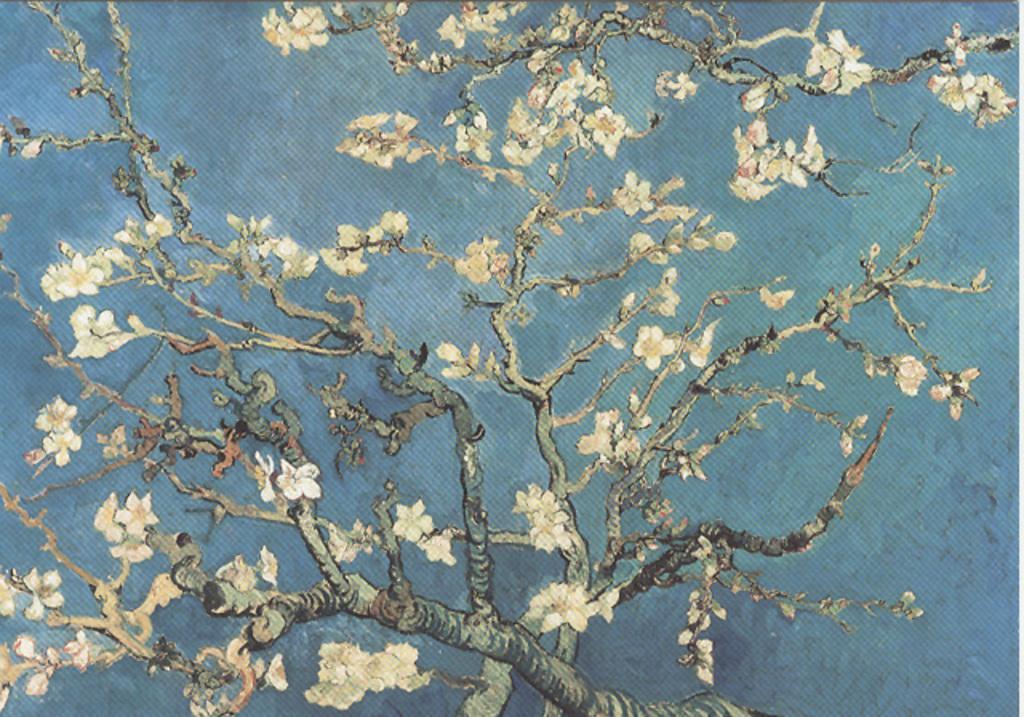Can you describe this image briefly? In this image there is painting of the tree on the carpet. 